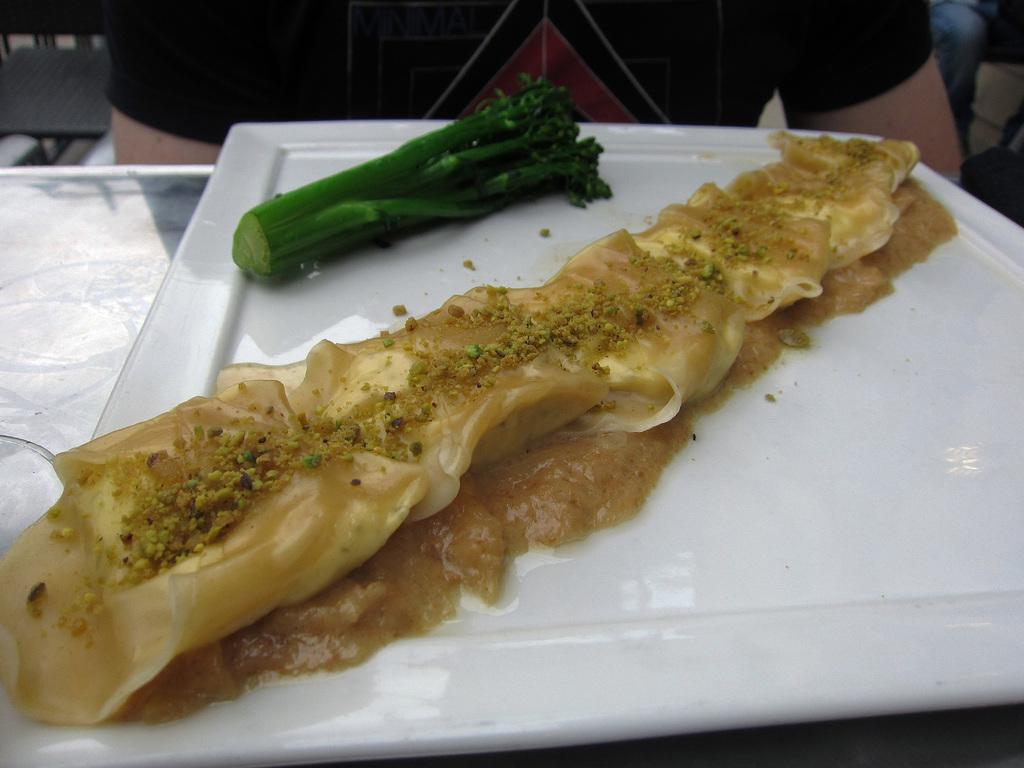What is on the plate that can be seen in the image? There are food items on a plate in the image. Where is the plate located? The plate is placed on a table. Can you describe any other elements in the image? A person's body is visible in the image. What type of stew is being served on the plate in the image? There is no stew mentioned or visible in the image; only food items are present on the plate. How many bananas are on the plate in the image? There is no mention of bananas in the image; only food items are present on the plate. 